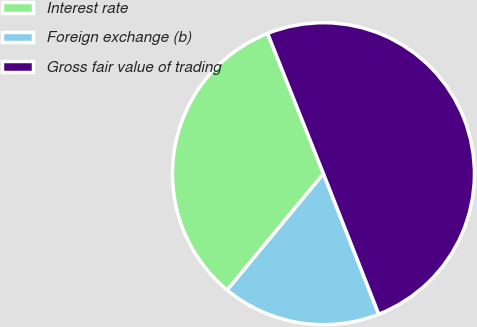Convert chart. <chart><loc_0><loc_0><loc_500><loc_500><pie_chart><fcel>Interest rate<fcel>Foreign exchange (b)<fcel>Gross fair value of trading<nl><fcel>32.97%<fcel>16.97%<fcel>50.06%<nl></chart> 